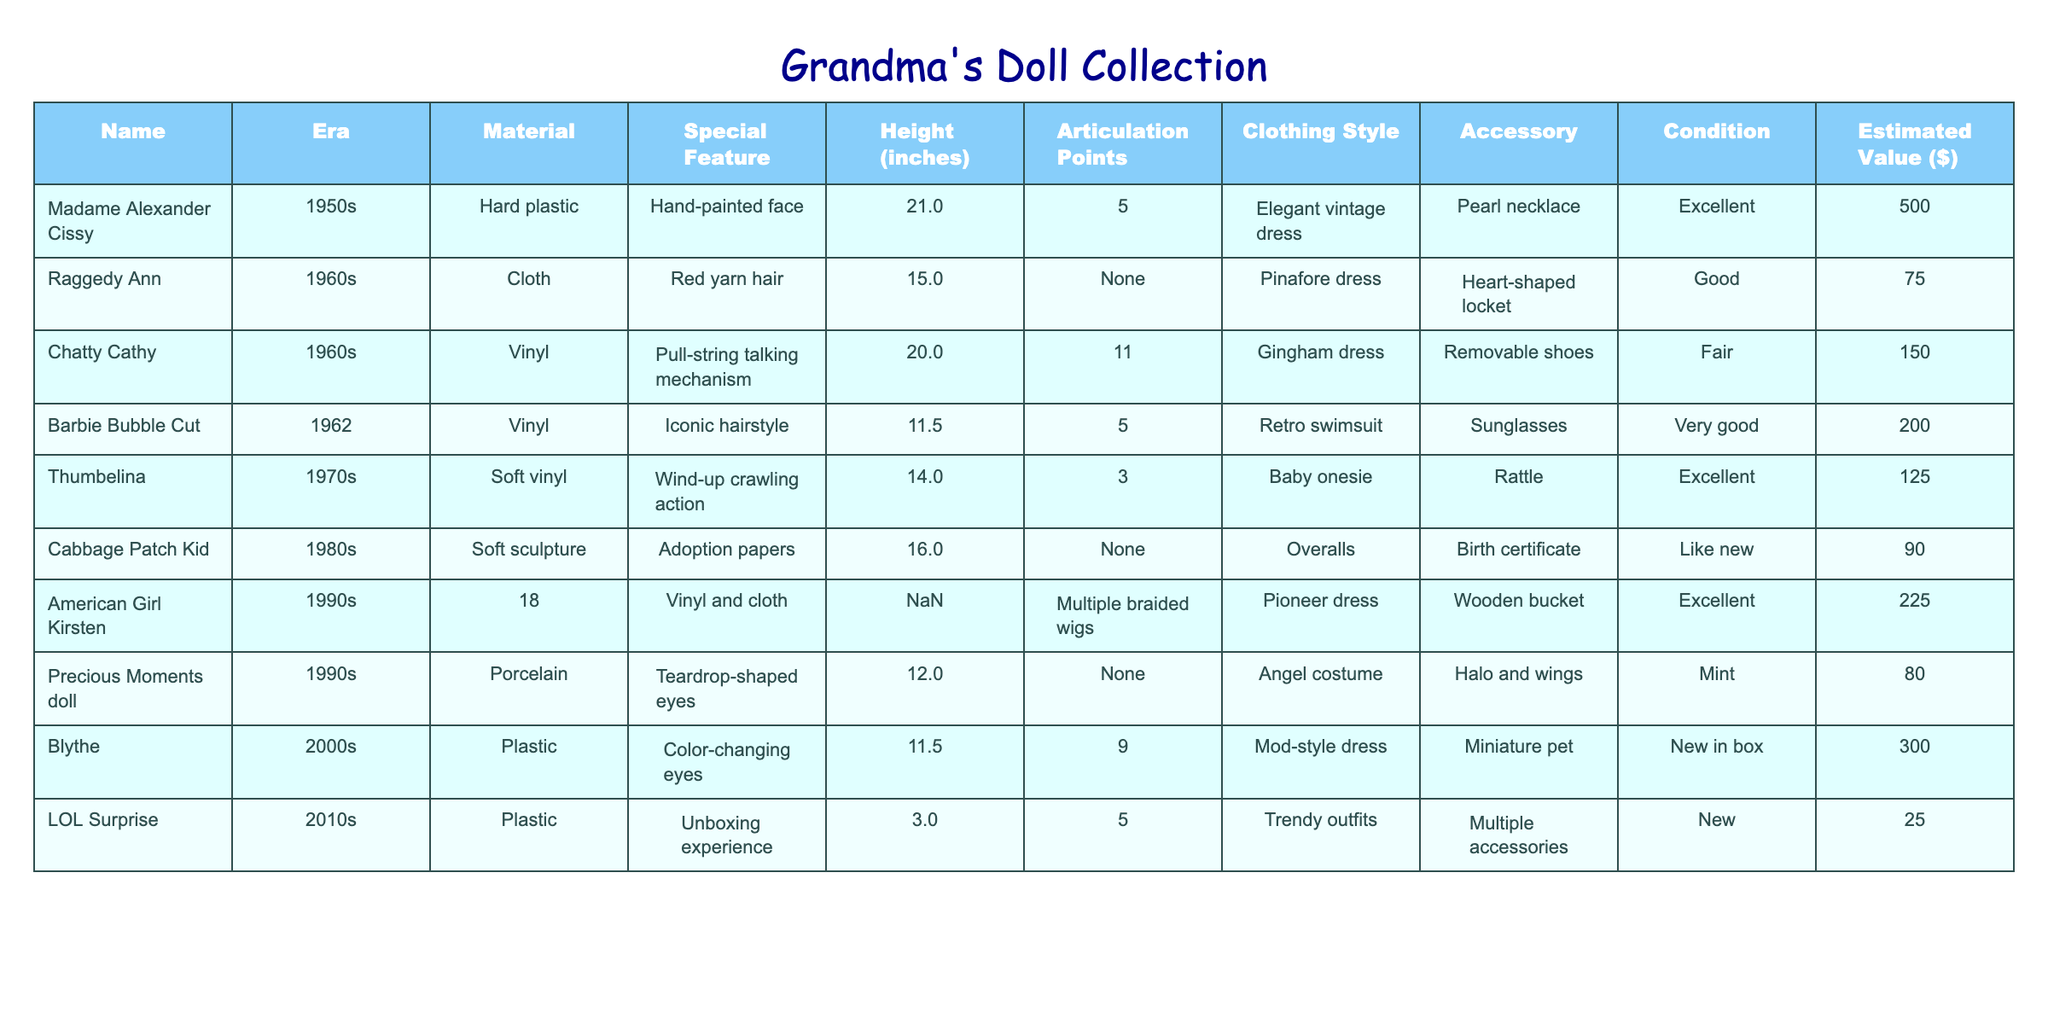What is the height of the Madame Alexander Cissy doll? The table shows that the height of the Madame Alexander Cissy doll is listed under the Height column. Looking at the row for this doll, the height is recorded as 21 inches.
Answer: 21 inches Which doll has the highest estimated value? By comparing the values in the Estimated Value column, we find that the Madame Alexander Cissy doll has the highest estimated value at $500, compared to the other dolls listed.
Answer: $500 Are all dolls in good condition? To answer this, we can check the Condition column for each doll. Several dolls, such as Raggedy Ann and Chatty Cathy, are labeled as 'Good' or 'Fair,' indicating that not all dolls are in good condition.
Answer: No What is the average height of the dolls from the 1960s? The dolls from the 1960s are Raggedy Ann (15 inches), Chatty Cathy (20 inches), and Barbie Bubble Cut (11.5 inches). Adding these heights gives us 15 + 20 + 11.5 = 46.5 inches. There are three dolls, so the average height is 46.5/3 = 15.5 inches.
Answer: 15.5 inches Which type of dolls have a special feature? We can look at the Special Feature column to identify which dolls have special features. All dolls listed have some special feature, like Hand-painted face for Madame Alexander Cissy or Pull-string talking mechanism for Chatty Cathy.
Answer: Yes What is the total estimated value of the dolls from the 1990s? The two dolls from the 1990s are American Girl Kirsten ($225) and Precious Moments doll ($80). Adding these values gives us a total of $225 + $80 = $305.
Answer: $305 How many articulation points does the Blythe doll have? Referring to the table, the articulation points for the Blythe doll are found in the Articulation Points column. It shows that the Blythe doll has 9 articulation points.
Answer: 9 Which doll has a unique accessory and what is it? We can look at the Accessory column to find unique accessories. The Thumbelina doll has a rattle as an accessory, which is uncommon compared to others that have items like a necklace or certificate.
Answer: Rattle What is the difference in estimated value between the highest and lowest valued dolls? The highest estimated value is the Madame Alexander Cissy at $500, while the lowest is the LOL Surprise at $25. The difference is calculated as $500 - $25 = $475.
Answer: $475 